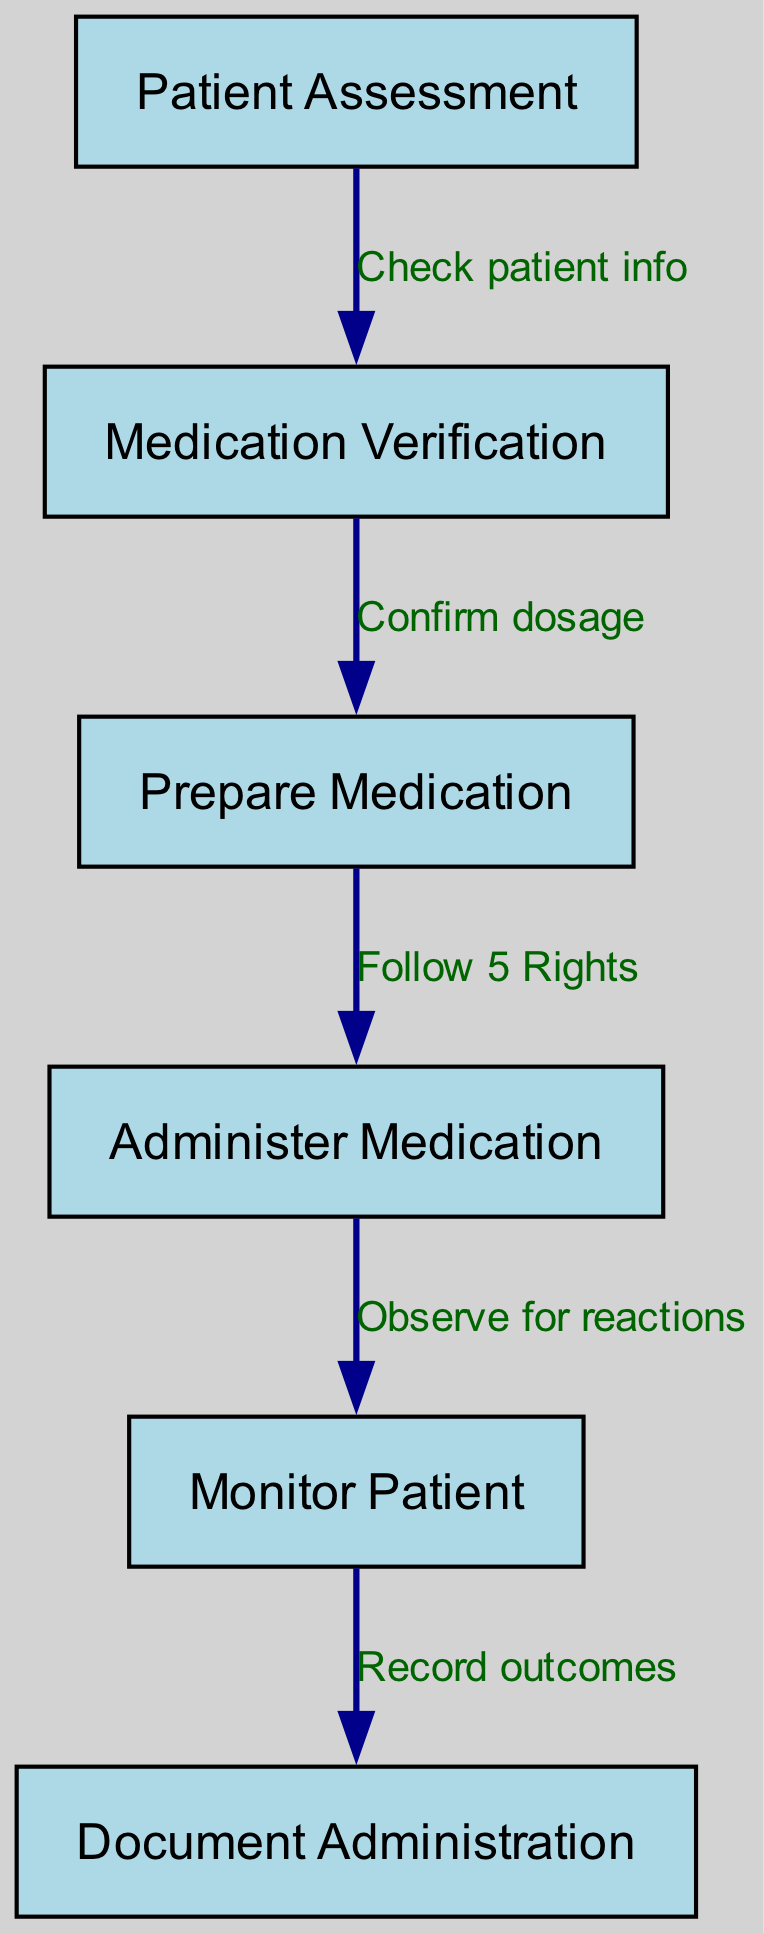What is the first step in the medication administration protocol? The diagram shows "Patient Assessment" as the first node, indicating it is the initial step in the protocol before moving to medication verification.
Answer: Patient Assessment How many nodes are present in the diagram? Counting the nodes listed in the diagram, there are a total of six distinct steps represented.
Answer: 6 What is the relationship between "Medication Verification" and "Prepare Medication"? The diagram shows a directed edge from "Medication Verification" to "Prepare Medication" with the label "Confirm dosage," signifying that confirming the dosage is necessary before preparation.
Answer: Confirm dosage Which step is directly after "Administer Medication"? According to the flow of the diagram, after "Administer Medication," the next step indicated is "Monitor Patient," highlighting the need for observation post-administration.
Answer: Monitor Patient What is documented after monitoring the patient? The diagram leads from "Monitor Patient" to "Document Administration," indicating that the outcomes of monitoring are formally recorded.
Answer: Document Administration What is the last step in the medication administration protocol? The final node in the diagram is "Document Administration," indicating that recording the administration is the last step in the flow of the protocol.
Answer: Document Administration Is there a direct link between "Patient Assessment" and "Administer Medication"? The diagram does not show a direct edge between "Patient Assessment" and "Administer Medication"; rather, there are intermediate steps (medication verification and preparation) that must occur first.
Answer: No How many edges are there in total in the diagram? The diagram includes five directed edges, illustrating the flow of processes between the different steps of the medication administration protocol.
Answer: 5 What labels are used to connect "Prepare Medication" and "Administer Medication"? The connection between these two nodes is labeled "Follow 5 Rights," indicating the importance of adhering to specific guidelines during medication administration.
Answer: Follow 5 Rights 